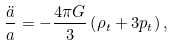Convert formula to latex. <formula><loc_0><loc_0><loc_500><loc_500>\frac { \ddot { a } } { a } = - \frac { 4 \pi G } { 3 } \left ( \rho _ { t } + 3 p _ { t } \right ) ,</formula> 